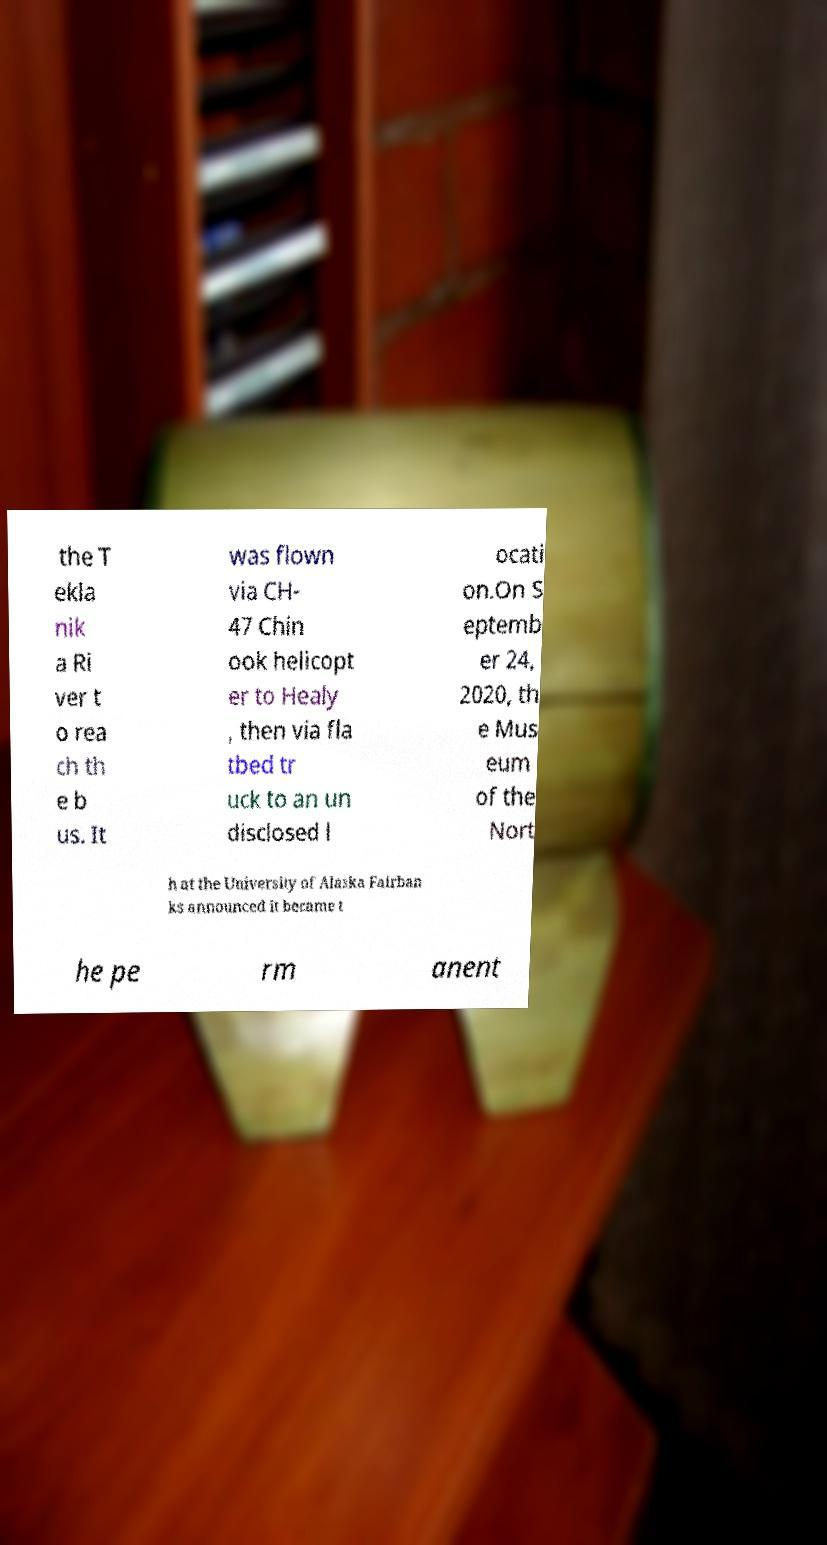Can you accurately transcribe the text from the provided image for me? the T ekla nik a Ri ver t o rea ch th e b us. It was flown via CH- 47 Chin ook helicopt er to Healy , then via fla tbed tr uck to an un disclosed l ocati on.On S eptemb er 24, 2020, th e Mus eum of the Nort h at the University of Alaska Fairban ks announced it became t he pe rm anent 